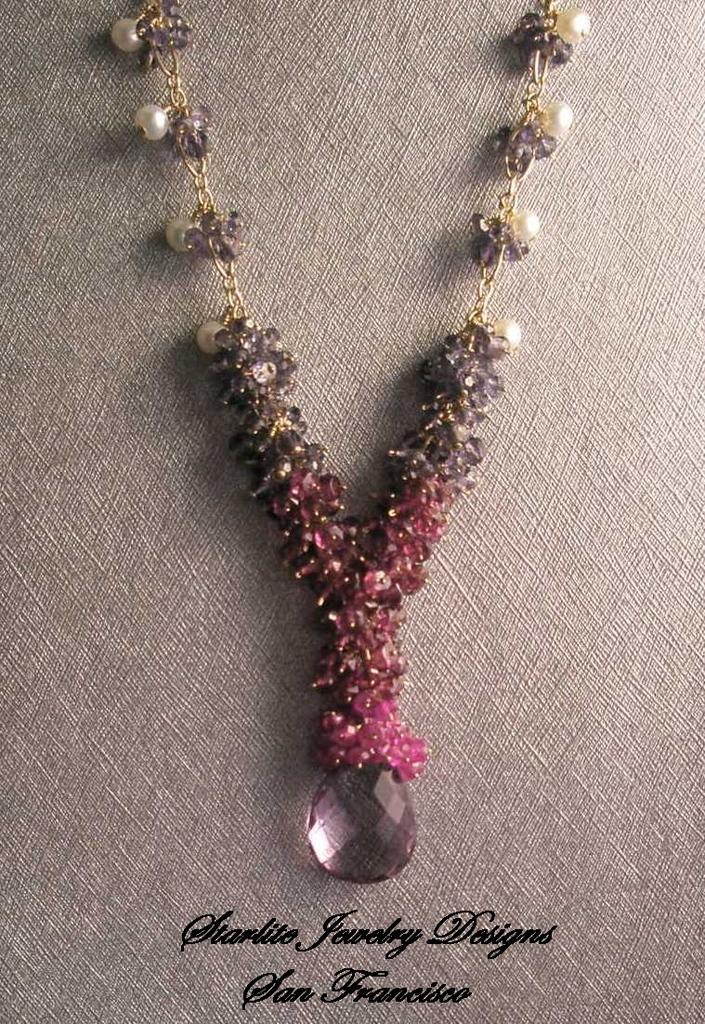Please provide a concise description of this image. In this image, we can see a necklace on an object. We can also see some text at the bottom. 